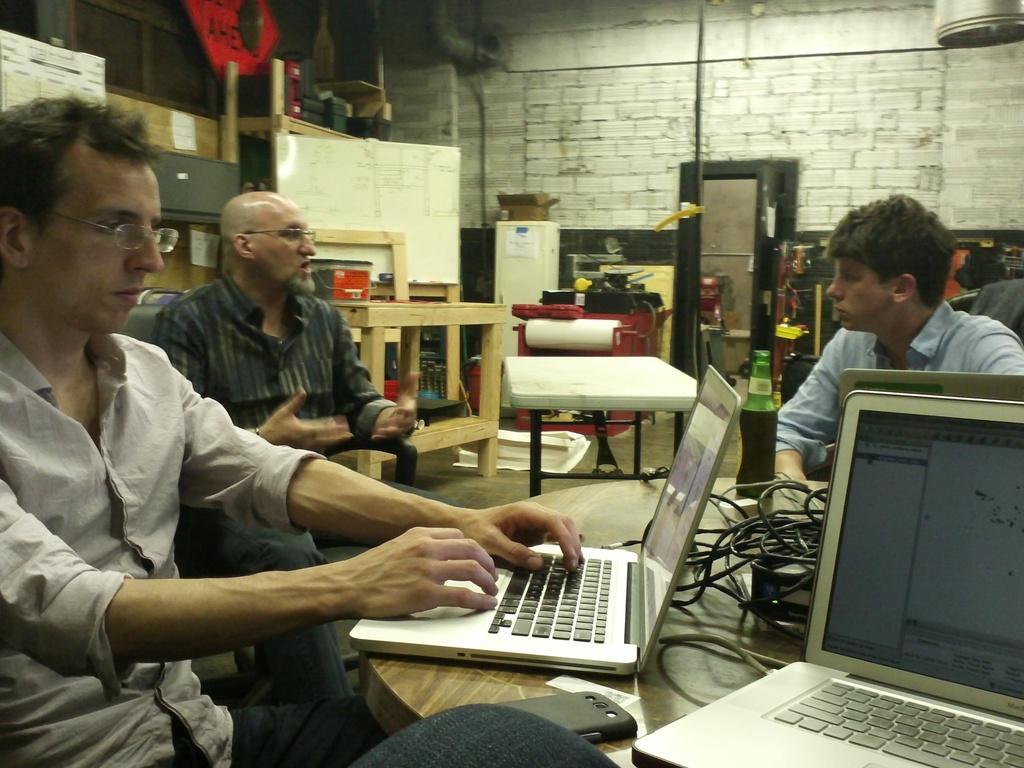Could you give a brief overview of what you see in this image? In this image there is a table on which laptops are there and some peoples are sitting on the chair and there are some tables which is in cream color and there is a wall which is in brown color. 